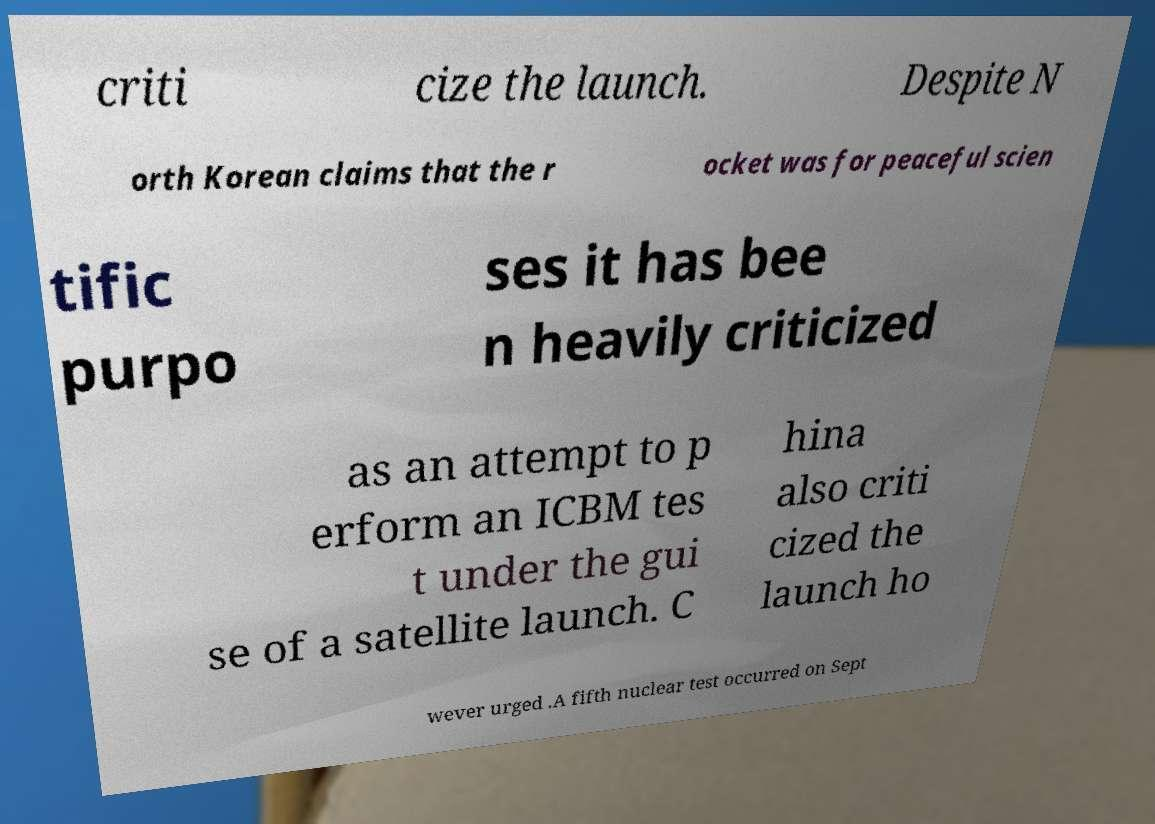For documentation purposes, I need the text within this image transcribed. Could you provide that? criti cize the launch. Despite N orth Korean claims that the r ocket was for peaceful scien tific purpo ses it has bee n heavily criticized as an attempt to p erform an ICBM tes t under the gui se of a satellite launch. C hina also criti cized the launch ho wever urged .A fifth nuclear test occurred on Sept 